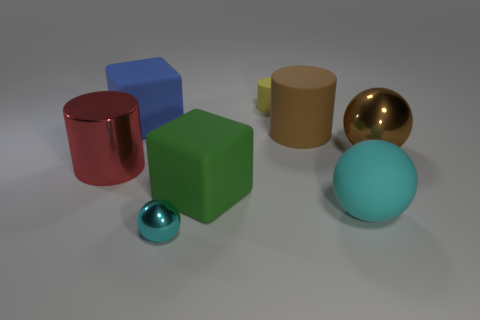Add 1 cyan shiny spheres. How many objects exist? 9 Subtract all spheres. How many objects are left? 5 Subtract 0 blue cylinders. How many objects are left? 8 Subtract all large spheres. Subtract all large cyan shiny spheres. How many objects are left? 6 Add 4 matte things. How many matte things are left? 9 Add 2 tiny things. How many tiny things exist? 4 